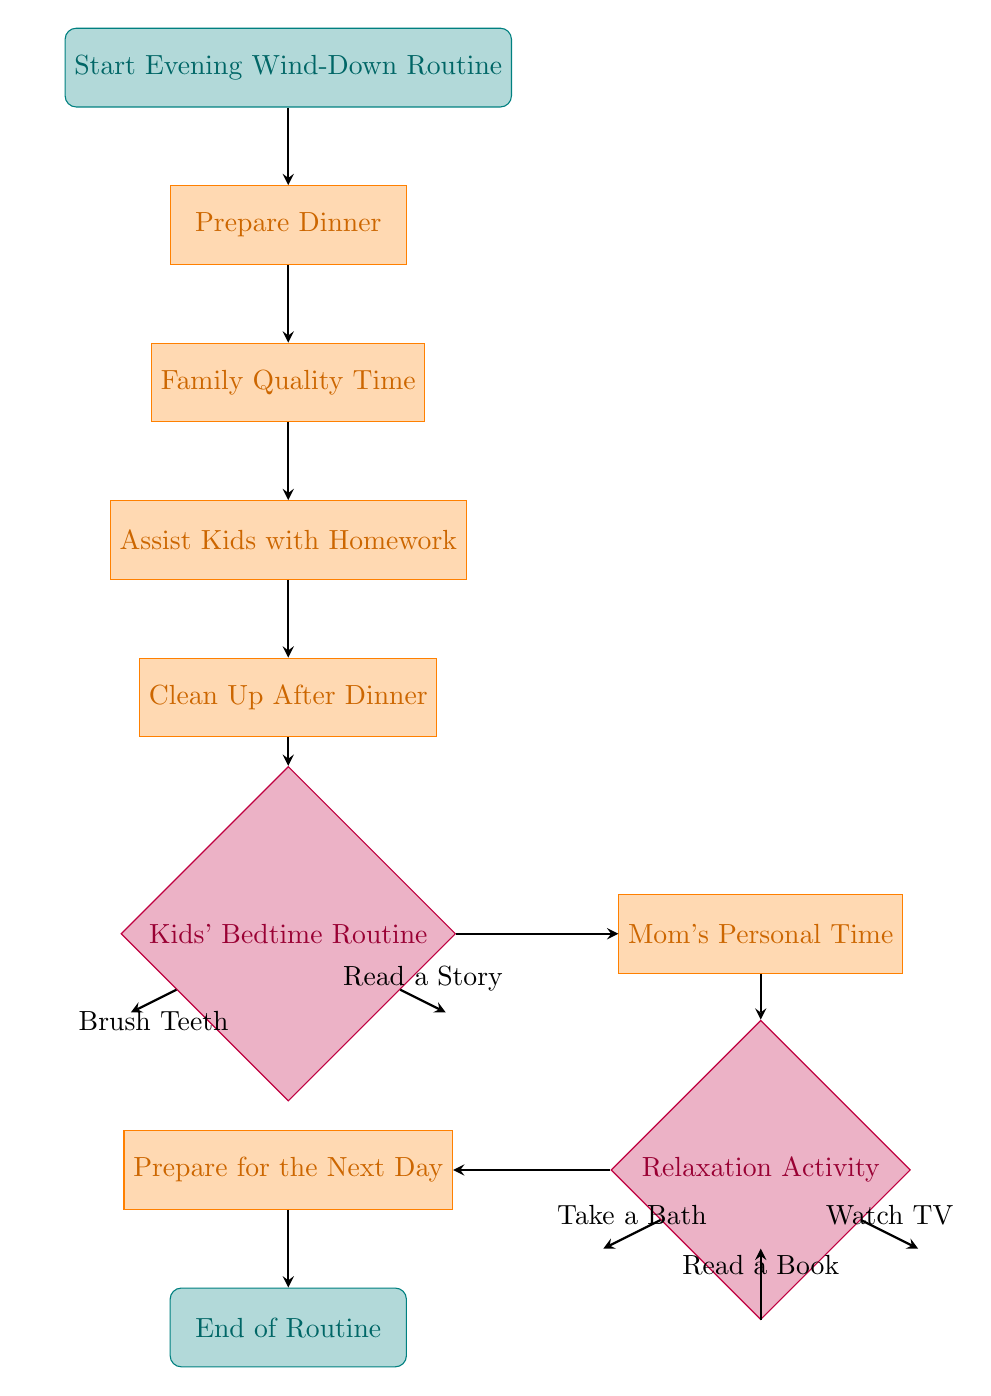What is the first step of the Evening Wind-Down Routine? The first node in the flow chart, labeled "Start Evening Wind-Down Routine," signifies the initiation of the process.
Answer: Start Evening Wind-Down Routine How many operations are there in the routine? Counting the nodes of type 'operation,' there are five operations: "Prepare Dinner," "Family Quality Time," "Assist Kids with Homework," "Clean Up After Dinner," and "Prepare for the Next Day."
Answer: 5 What decision follows the "Clean Up After Dinner"? The flow chart indicates that the node that follows "Clean Up After Dinner" is "Kids' Bedtime Routine," which is a decision point.
Answer: Kids' Bedtime Routine What happens after "Mom's Personal Time"? From the "Mom's Personal Time" node, the next step in the routine is to engage in a "Relaxation Activity."
Answer: Relaxation Activity If the choice in "Kids' Bedtime Routine" is "Brush Teeth," what is the next activity? If "Brush Teeth" is chosen at the "Kids' Bedtime Routine," the routine directly flows back to "Mom's Personal Time" without going through the "Read a Story" option. Thus, "Mom's Personal Time" follows.
Answer: Mom's Personal Time Which activity is an option after "Relaxation Activity"? After "Relaxation Activity," the routine continues to "Prepare for the Next Day," regardless of the chosen relaxation option.
Answer: Prepare for the Next Day How many choices are there in the "Kids' Bedtime Routine"? The decision node "Kids' Bedtime Routine" presents two choices: "Read a Story" and "Brush Teeth." Thus, the number of choices is two.
Answer: 2 What are the last two activities in the routine? The last two steps in the flow chart are "Prepare for the Next Day," which leads to "End of Routine." These steps conclude the evening routine.
Answer: Prepare for the Next Day, End of Routine 